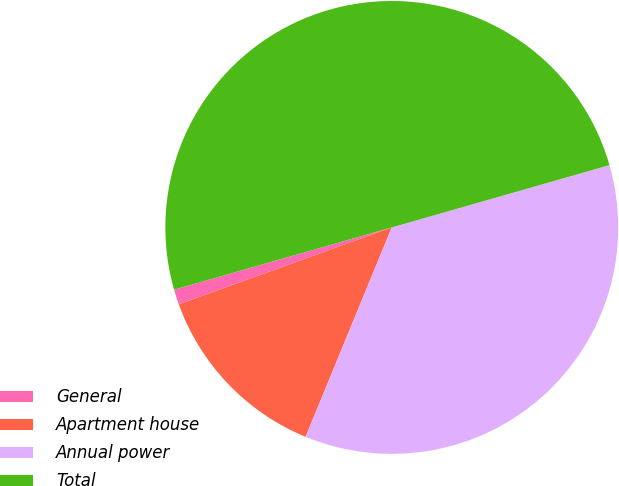Convert chart to OTSL. <chart><loc_0><loc_0><loc_500><loc_500><pie_chart><fcel>General<fcel>Apartment house<fcel>Annual power<fcel>Total<nl><fcel>1.08%<fcel>13.27%<fcel>35.65%<fcel>50.0%<nl></chart> 